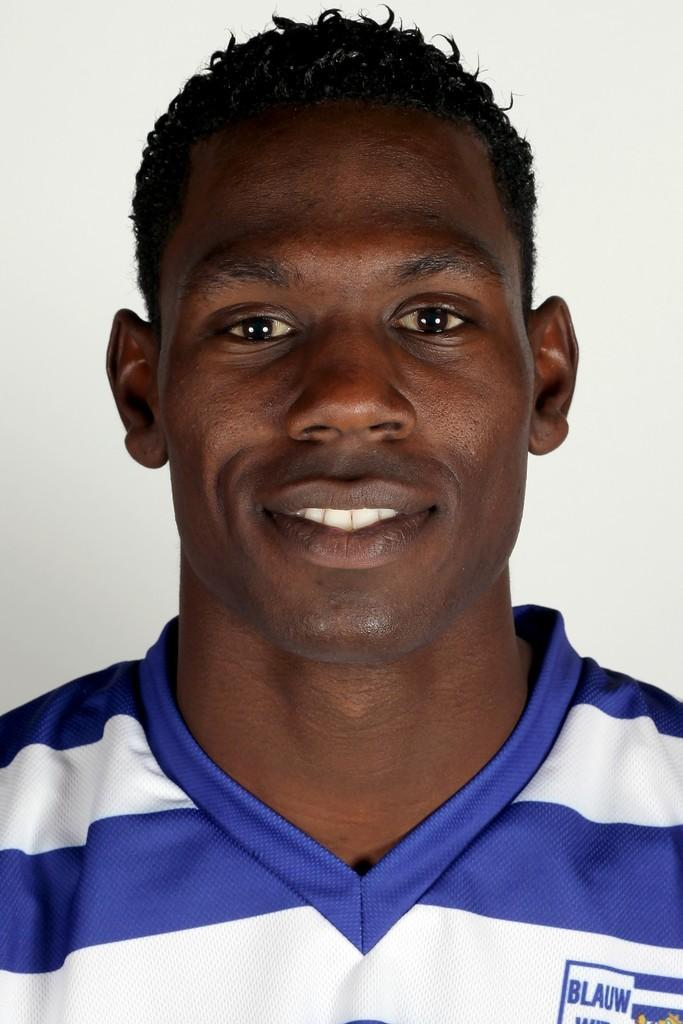<image>
Share a concise interpretation of the image provided. A man has a striped shirt on with BLAUW on the front. 